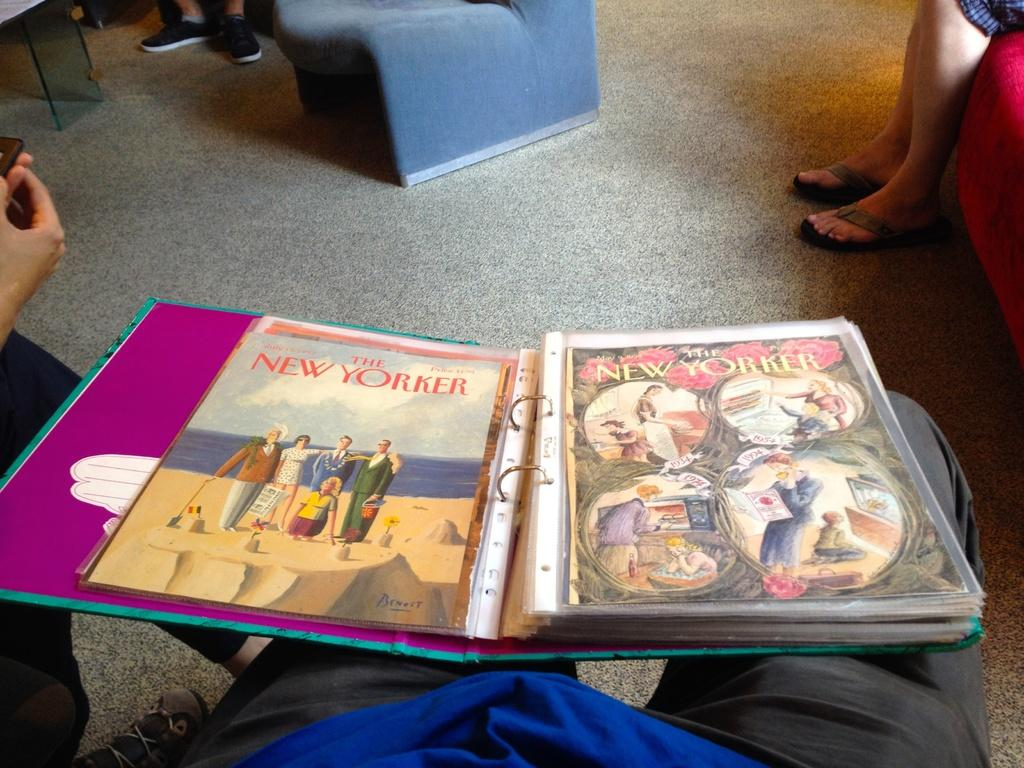<image>
Relay a brief, clear account of the picture shown. a binder with pages on it titled 'the new yorker' 